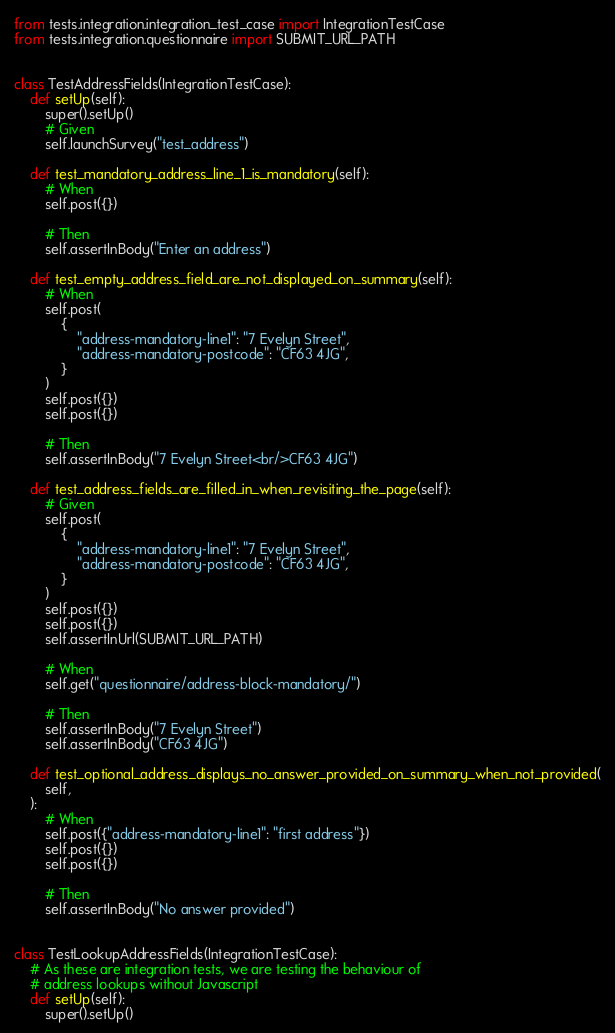<code> <loc_0><loc_0><loc_500><loc_500><_Python_>from tests.integration.integration_test_case import IntegrationTestCase
from tests.integration.questionnaire import SUBMIT_URL_PATH


class TestAddressFields(IntegrationTestCase):
    def setUp(self):
        super().setUp()
        # Given
        self.launchSurvey("test_address")

    def test_mandatory_address_line_1_is_mandatory(self):
        # When
        self.post({})

        # Then
        self.assertInBody("Enter an address")

    def test_empty_address_field_are_not_displayed_on_summary(self):
        # When
        self.post(
            {
                "address-mandatory-line1": "7 Evelyn Street",
                "address-mandatory-postcode": "CF63 4JG",
            }
        )
        self.post({})
        self.post({})

        # Then
        self.assertInBody("7 Evelyn Street<br/>CF63 4JG")

    def test_address_fields_are_filled_in_when_revisiting_the_page(self):
        # Given
        self.post(
            {
                "address-mandatory-line1": "7 Evelyn Street",
                "address-mandatory-postcode": "CF63 4JG",
            }
        )
        self.post({})
        self.post({})
        self.assertInUrl(SUBMIT_URL_PATH)

        # When
        self.get("questionnaire/address-block-mandatory/")

        # Then
        self.assertInBody("7 Evelyn Street")
        self.assertInBody("CF63 4JG")

    def test_optional_address_displays_no_answer_provided_on_summary_when_not_provided(
        self,
    ):
        # When
        self.post({"address-mandatory-line1": "first address"})
        self.post({})
        self.post({})

        # Then
        self.assertInBody("No answer provided")


class TestLookupAddressFields(IntegrationTestCase):
    # As these are integration tests, we are testing the behaviour of
    # address lookups without Javascript
    def setUp(self):
        super().setUp()</code> 